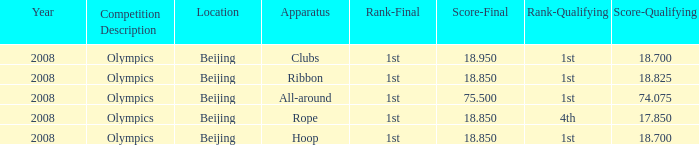What was her lowest final score with a qualifying score of 74.075? 75.5. 